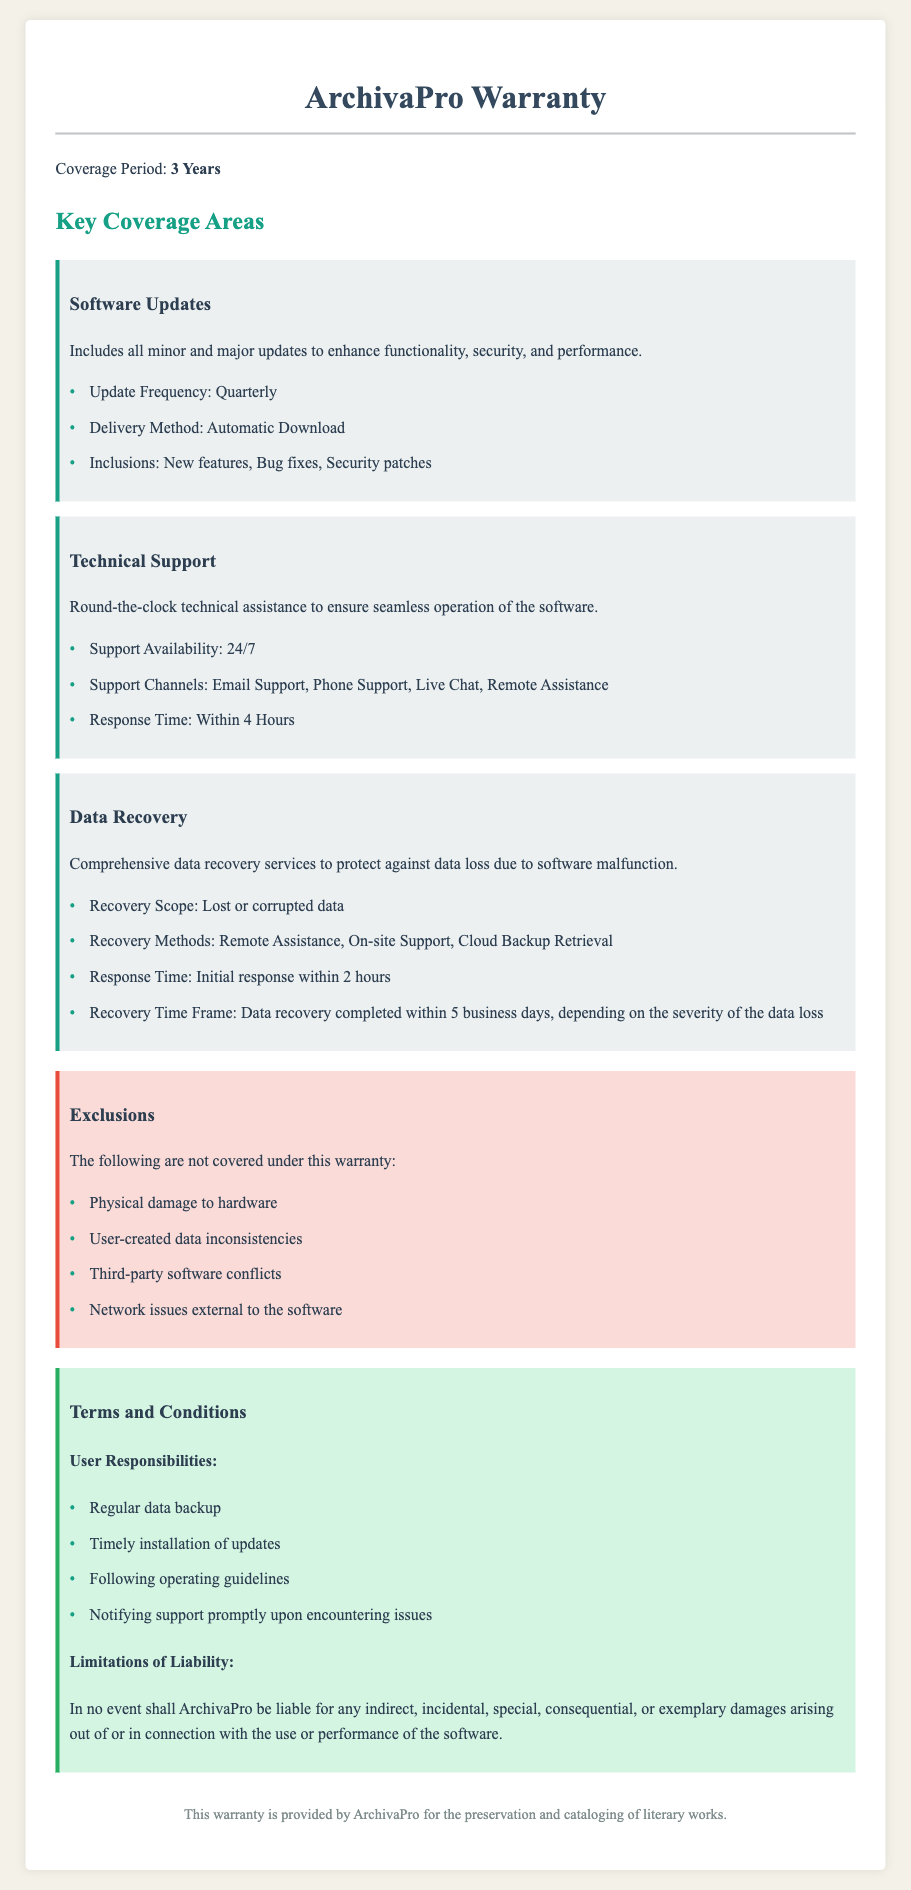What is the coverage period of the warranty? The coverage period is explicitly stated in the document as three years.
Answer: 3 Years What is the frequency of software updates? The document specifies the frequency of updates as quarterly, making it a key point of reference.
Answer: Quarterly How soon can users expect a response from technical support? The response time for technical support is highlighted, and it is stated as within 4 hours.
Answer: Within 4 Hours What recovery methods are mentioned for data recovery? The document lists the recovery methods available, including remote assistance and on-site support.
Answer: Remote Assistance, On-site Support, Cloud Backup Retrieval Which types of damages are excluded from the warranty? The document lists exclusions, clearly stating that physical damage to hardware is not covered.
Answer: Physical damage to hardware What are user responsibilities related to data backup? User responsibilities include several key actions; one of them is a regular data backup to ensure data safety.
Answer: Regular data backup What is the recovery time frame for data recovery? The document outlines a recovery time frame that specifies when to expect completion based on severity.
Answer: Within 5 business days What type of damages is ArchivaPro not liable for? The warranty details limitations of liability indicating certain damages are excluded, such as consequential damages.
Answer: Indirect, incidental, special, consequential, or exemplary damages What methods are available for technical support? The document lists multiple support channels available to users, making it clear that they can seek help through various methods.
Answer: Email Support, Phone Support, Live Chat, Remote Assistance 